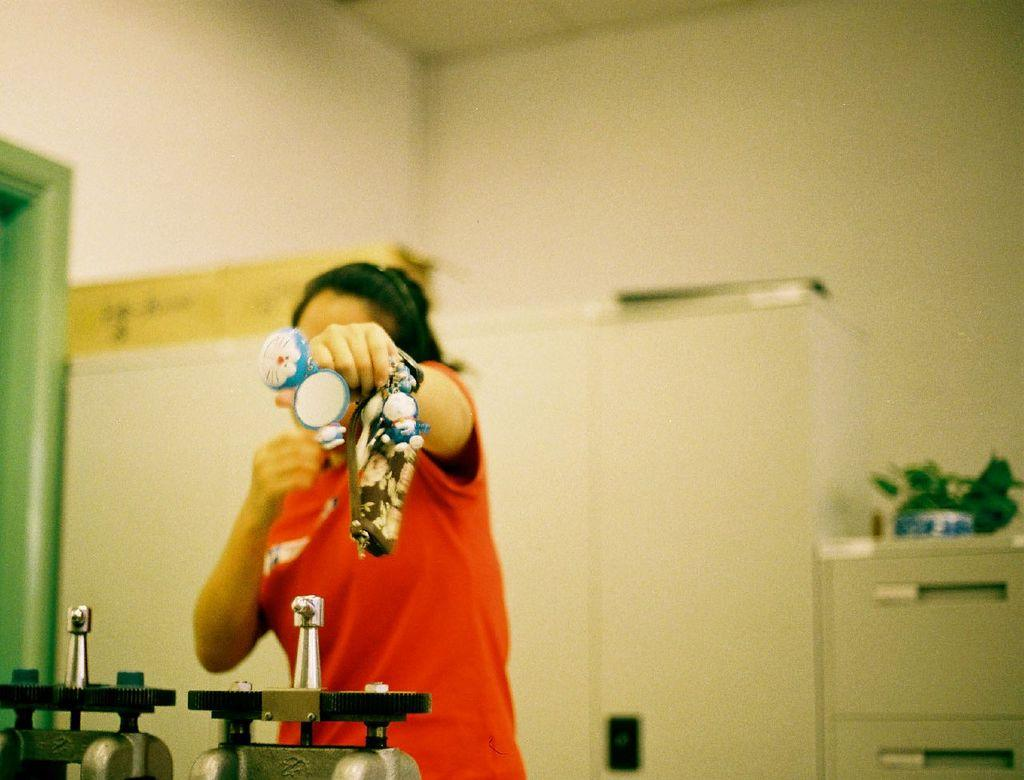What is the person in the image doing? The person is standing in the image. What is the person holding in the image? The person is holding an object. What can be seen in the background of the image? There is a wall and an object on a table in the background of the image. What else is visible in the image besides the person and the wall? There are equipment visible in the image. What type of offer is the baby making in the image? There is no baby present in the image, so no offer can be made. 